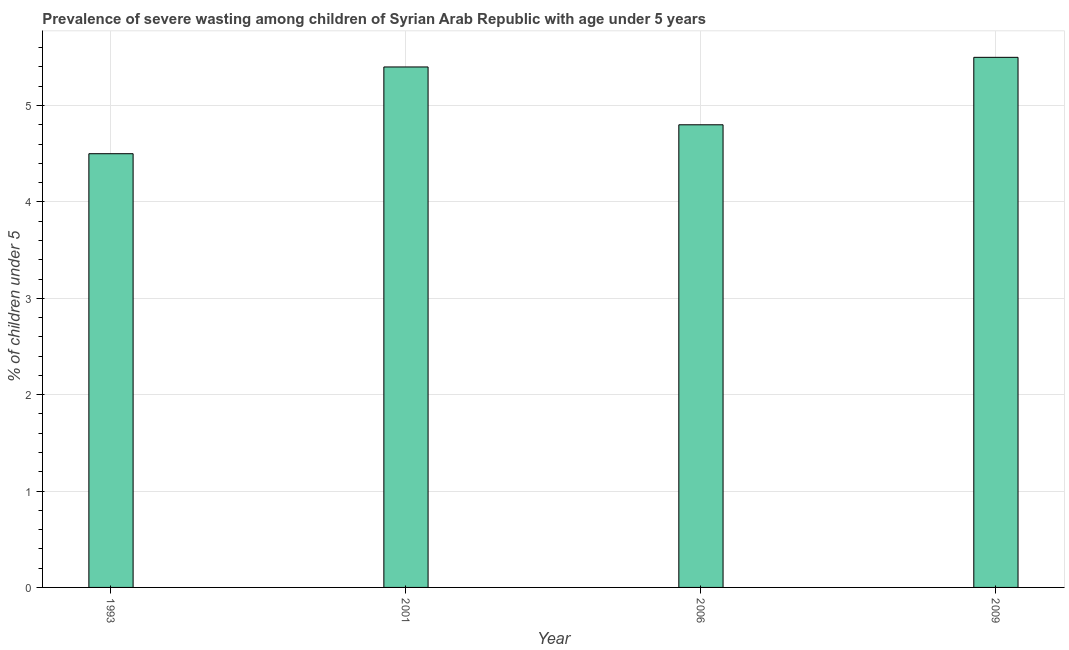Does the graph contain any zero values?
Give a very brief answer. No. What is the title of the graph?
Give a very brief answer. Prevalence of severe wasting among children of Syrian Arab Republic with age under 5 years. What is the label or title of the X-axis?
Your answer should be very brief. Year. What is the label or title of the Y-axis?
Your answer should be compact.  % of children under 5. What is the prevalence of severe wasting in 2001?
Keep it short and to the point. 5.4. Across all years, what is the maximum prevalence of severe wasting?
Your response must be concise. 5.5. In which year was the prevalence of severe wasting minimum?
Offer a very short reply. 1993. What is the sum of the prevalence of severe wasting?
Make the answer very short. 20.2. What is the difference between the prevalence of severe wasting in 1993 and 2009?
Ensure brevity in your answer.  -1. What is the average prevalence of severe wasting per year?
Make the answer very short. 5.05. What is the median prevalence of severe wasting?
Provide a short and direct response. 5.1. In how many years, is the prevalence of severe wasting greater than 1.4 %?
Your answer should be very brief. 4. Do a majority of the years between 1993 and 2001 (inclusive) have prevalence of severe wasting greater than 3.2 %?
Keep it short and to the point. Yes. What is the ratio of the prevalence of severe wasting in 2001 to that in 2009?
Provide a succinct answer. 0.98. What is the difference between the highest and the second highest prevalence of severe wasting?
Make the answer very short. 0.1. Is the sum of the prevalence of severe wasting in 1993 and 2006 greater than the maximum prevalence of severe wasting across all years?
Keep it short and to the point. Yes. What is the difference between the highest and the lowest prevalence of severe wasting?
Give a very brief answer. 1. How many bars are there?
Provide a short and direct response. 4. Are all the bars in the graph horizontal?
Give a very brief answer. No. How many years are there in the graph?
Offer a terse response. 4. What is the difference between two consecutive major ticks on the Y-axis?
Your response must be concise. 1. What is the  % of children under 5 of 1993?
Offer a terse response. 4.5. What is the  % of children under 5 in 2001?
Your response must be concise. 5.4. What is the  % of children under 5 in 2006?
Ensure brevity in your answer.  4.8. What is the difference between the  % of children under 5 in 1993 and 2001?
Provide a succinct answer. -0.9. What is the difference between the  % of children under 5 in 1993 and 2006?
Keep it short and to the point. -0.3. What is the difference between the  % of children under 5 in 2001 and 2009?
Your response must be concise. -0.1. What is the ratio of the  % of children under 5 in 1993 to that in 2001?
Offer a terse response. 0.83. What is the ratio of the  % of children under 5 in 1993 to that in 2006?
Your response must be concise. 0.94. What is the ratio of the  % of children under 5 in 1993 to that in 2009?
Keep it short and to the point. 0.82. What is the ratio of the  % of children under 5 in 2006 to that in 2009?
Provide a succinct answer. 0.87. 